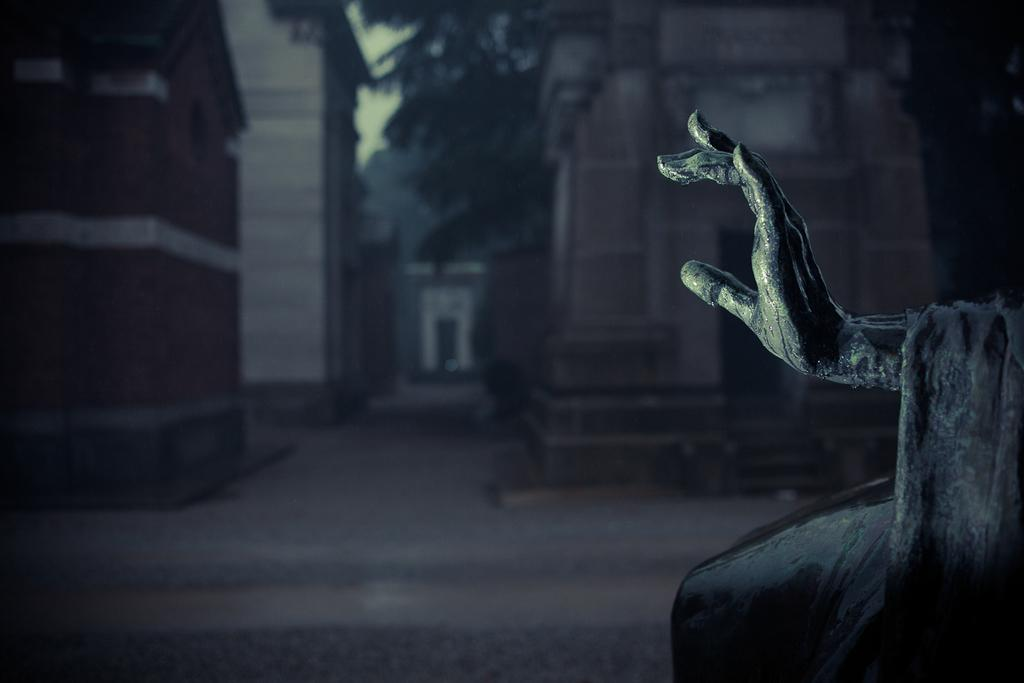What is the color scheme of the image? The image is black and white. What part of a statue can be seen in the image? There is a statue's hand in the image. On which side of the image is the statue's hand located? The statue's hand is on the right side of the image. How would you describe the background of the image? The background of the image is blurred. What type of structures can be seen in the image? There are buildings visible in the image. What type of vegetation is present in the image? There are trees in the image. What type of farm animals can be seen in the image? There are no farm animals present in the image. How many toads are sitting on the statue's hand in the image? There are no toads present in the image, and the statue's hand is not holding anything. 